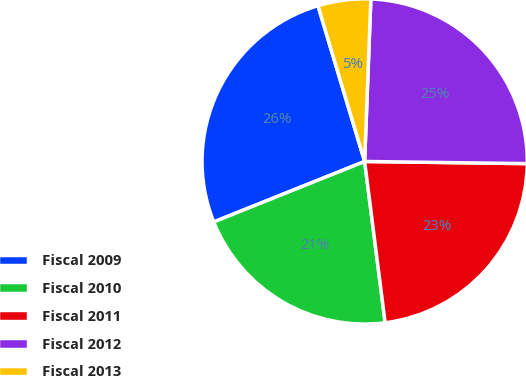<chart> <loc_0><loc_0><loc_500><loc_500><pie_chart><fcel>Fiscal 2009<fcel>Fiscal 2010<fcel>Fiscal 2011<fcel>Fiscal 2012<fcel>Fiscal 2013<nl><fcel>26.44%<fcel>20.95%<fcel>22.78%<fcel>24.61%<fcel>5.24%<nl></chart> 